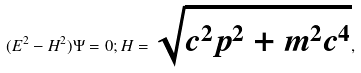Convert formula to latex. <formula><loc_0><loc_0><loc_500><loc_500>( E ^ { 2 } - H ^ { 2 } ) \Psi = 0 ; H = \sqrt { c ^ { 2 } { p } ^ { 2 } + m ^ { 2 } c ^ { 4 } } ,</formula> 